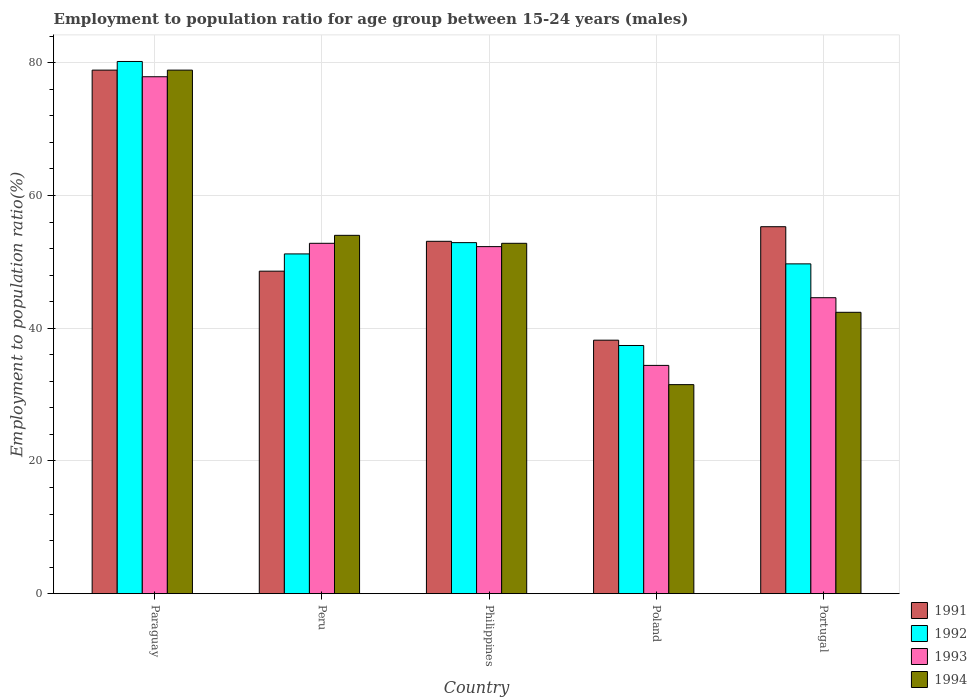How many different coloured bars are there?
Make the answer very short. 4. Are the number of bars on each tick of the X-axis equal?
Your answer should be compact. Yes. How many bars are there on the 4th tick from the left?
Make the answer very short. 4. How many bars are there on the 4th tick from the right?
Give a very brief answer. 4. What is the label of the 2nd group of bars from the left?
Ensure brevity in your answer.  Peru. What is the employment to population ratio in 1992 in Paraguay?
Offer a very short reply. 80.2. Across all countries, what is the maximum employment to population ratio in 1993?
Give a very brief answer. 77.9. Across all countries, what is the minimum employment to population ratio in 1991?
Provide a succinct answer. 38.2. In which country was the employment to population ratio in 1993 maximum?
Provide a short and direct response. Paraguay. What is the total employment to population ratio in 1991 in the graph?
Your answer should be very brief. 274.1. What is the difference between the employment to population ratio in 1991 in Peru and that in Portugal?
Provide a succinct answer. -6.7. What is the difference between the employment to population ratio in 1994 in Portugal and the employment to population ratio in 1992 in Poland?
Keep it short and to the point. 5. What is the average employment to population ratio in 1992 per country?
Provide a short and direct response. 54.28. What is the difference between the employment to population ratio of/in 1993 and employment to population ratio of/in 1991 in Poland?
Your response must be concise. -3.8. In how many countries, is the employment to population ratio in 1992 greater than 44 %?
Give a very brief answer. 4. What is the ratio of the employment to population ratio in 1992 in Paraguay to that in Portugal?
Keep it short and to the point. 1.61. What is the difference between the highest and the second highest employment to population ratio in 1994?
Offer a very short reply. 1.2. What is the difference between the highest and the lowest employment to population ratio in 1994?
Make the answer very short. 47.4. In how many countries, is the employment to population ratio in 1992 greater than the average employment to population ratio in 1992 taken over all countries?
Your answer should be very brief. 1. Is the sum of the employment to population ratio in 1992 in Peru and Philippines greater than the maximum employment to population ratio in 1993 across all countries?
Offer a terse response. Yes. Is it the case that in every country, the sum of the employment to population ratio in 1992 and employment to population ratio in 1991 is greater than the sum of employment to population ratio in 1994 and employment to population ratio in 1993?
Your answer should be compact. No. How many bars are there?
Give a very brief answer. 20. Are the values on the major ticks of Y-axis written in scientific E-notation?
Ensure brevity in your answer.  No. What is the title of the graph?
Your answer should be very brief. Employment to population ratio for age group between 15-24 years (males). Does "1980" appear as one of the legend labels in the graph?
Provide a succinct answer. No. What is the label or title of the X-axis?
Your answer should be compact. Country. What is the Employment to population ratio(%) in 1991 in Paraguay?
Keep it short and to the point. 78.9. What is the Employment to population ratio(%) in 1992 in Paraguay?
Your answer should be very brief. 80.2. What is the Employment to population ratio(%) of 1993 in Paraguay?
Offer a very short reply. 77.9. What is the Employment to population ratio(%) in 1994 in Paraguay?
Your response must be concise. 78.9. What is the Employment to population ratio(%) in 1991 in Peru?
Your response must be concise. 48.6. What is the Employment to population ratio(%) of 1992 in Peru?
Offer a very short reply. 51.2. What is the Employment to population ratio(%) of 1993 in Peru?
Provide a succinct answer. 52.8. What is the Employment to population ratio(%) in 1994 in Peru?
Your response must be concise. 54. What is the Employment to population ratio(%) of 1991 in Philippines?
Ensure brevity in your answer.  53.1. What is the Employment to population ratio(%) in 1992 in Philippines?
Offer a very short reply. 52.9. What is the Employment to population ratio(%) of 1993 in Philippines?
Your answer should be very brief. 52.3. What is the Employment to population ratio(%) of 1994 in Philippines?
Provide a short and direct response. 52.8. What is the Employment to population ratio(%) in 1991 in Poland?
Give a very brief answer. 38.2. What is the Employment to population ratio(%) of 1992 in Poland?
Your answer should be very brief. 37.4. What is the Employment to population ratio(%) of 1993 in Poland?
Your answer should be compact. 34.4. What is the Employment to population ratio(%) in 1994 in Poland?
Provide a succinct answer. 31.5. What is the Employment to population ratio(%) in 1991 in Portugal?
Ensure brevity in your answer.  55.3. What is the Employment to population ratio(%) in 1992 in Portugal?
Provide a succinct answer. 49.7. What is the Employment to population ratio(%) in 1993 in Portugal?
Provide a short and direct response. 44.6. What is the Employment to population ratio(%) in 1994 in Portugal?
Keep it short and to the point. 42.4. Across all countries, what is the maximum Employment to population ratio(%) in 1991?
Provide a short and direct response. 78.9. Across all countries, what is the maximum Employment to population ratio(%) in 1992?
Make the answer very short. 80.2. Across all countries, what is the maximum Employment to population ratio(%) in 1993?
Provide a short and direct response. 77.9. Across all countries, what is the maximum Employment to population ratio(%) of 1994?
Your answer should be very brief. 78.9. Across all countries, what is the minimum Employment to population ratio(%) in 1991?
Your answer should be compact. 38.2. Across all countries, what is the minimum Employment to population ratio(%) in 1992?
Ensure brevity in your answer.  37.4. Across all countries, what is the minimum Employment to population ratio(%) of 1993?
Offer a terse response. 34.4. Across all countries, what is the minimum Employment to population ratio(%) in 1994?
Provide a short and direct response. 31.5. What is the total Employment to population ratio(%) of 1991 in the graph?
Offer a terse response. 274.1. What is the total Employment to population ratio(%) in 1992 in the graph?
Ensure brevity in your answer.  271.4. What is the total Employment to population ratio(%) in 1993 in the graph?
Your answer should be very brief. 262. What is the total Employment to population ratio(%) of 1994 in the graph?
Your answer should be very brief. 259.6. What is the difference between the Employment to population ratio(%) of 1991 in Paraguay and that in Peru?
Give a very brief answer. 30.3. What is the difference between the Employment to population ratio(%) of 1993 in Paraguay and that in Peru?
Offer a terse response. 25.1. What is the difference between the Employment to population ratio(%) in 1994 in Paraguay and that in Peru?
Provide a short and direct response. 24.9. What is the difference between the Employment to population ratio(%) in 1991 in Paraguay and that in Philippines?
Provide a succinct answer. 25.8. What is the difference between the Employment to population ratio(%) in 1992 in Paraguay and that in Philippines?
Your answer should be compact. 27.3. What is the difference between the Employment to population ratio(%) of 1993 in Paraguay and that in Philippines?
Ensure brevity in your answer.  25.6. What is the difference between the Employment to population ratio(%) in 1994 in Paraguay and that in Philippines?
Keep it short and to the point. 26.1. What is the difference between the Employment to population ratio(%) in 1991 in Paraguay and that in Poland?
Keep it short and to the point. 40.7. What is the difference between the Employment to population ratio(%) of 1992 in Paraguay and that in Poland?
Offer a terse response. 42.8. What is the difference between the Employment to population ratio(%) of 1993 in Paraguay and that in Poland?
Offer a terse response. 43.5. What is the difference between the Employment to population ratio(%) in 1994 in Paraguay and that in Poland?
Your answer should be very brief. 47.4. What is the difference between the Employment to population ratio(%) in 1991 in Paraguay and that in Portugal?
Your answer should be compact. 23.6. What is the difference between the Employment to population ratio(%) in 1992 in Paraguay and that in Portugal?
Offer a terse response. 30.5. What is the difference between the Employment to population ratio(%) of 1993 in Paraguay and that in Portugal?
Your answer should be compact. 33.3. What is the difference between the Employment to population ratio(%) of 1994 in Paraguay and that in Portugal?
Ensure brevity in your answer.  36.5. What is the difference between the Employment to population ratio(%) of 1991 in Peru and that in Philippines?
Provide a succinct answer. -4.5. What is the difference between the Employment to population ratio(%) of 1992 in Peru and that in Philippines?
Ensure brevity in your answer.  -1.7. What is the difference between the Employment to population ratio(%) in 1993 in Peru and that in Philippines?
Give a very brief answer. 0.5. What is the difference between the Employment to population ratio(%) in 1994 in Peru and that in Philippines?
Ensure brevity in your answer.  1.2. What is the difference between the Employment to population ratio(%) of 1992 in Peru and that in Poland?
Make the answer very short. 13.8. What is the difference between the Employment to population ratio(%) in 1992 in Peru and that in Portugal?
Offer a terse response. 1.5. What is the difference between the Employment to population ratio(%) of 1993 in Peru and that in Portugal?
Make the answer very short. 8.2. What is the difference between the Employment to population ratio(%) in 1994 in Peru and that in Portugal?
Ensure brevity in your answer.  11.6. What is the difference between the Employment to population ratio(%) in 1992 in Philippines and that in Poland?
Your response must be concise. 15.5. What is the difference between the Employment to population ratio(%) in 1994 in Philippines and that in Poland?
Your answer should be compact. 21.3. What is the difference between the Employment to population ratio(%) in 1992 in Philippines and that in Portugal?
Your answer should be compact. 3.2. What is the difference between the Employment to population ratio(%) in 1993 in Philippines and that in Portugal?
Give a very brief answer. 7.7. What is the difference between the Employment to population ratio(%) of 1991 in Poland and that in Portugal?
Your response must be concise. -17.1. What is the difference between the Employment to population ratio(%) of 1993 in Poland and that in Portugal?
Offer a terse response. -10.2. What is the difference between the Employment to population ratio(%) of 1994 in Poland and that in Portugal?
Offer a terse response. -10.9. What is the difference between the Employment to population ratio(%) in 1991 in Paraguay and the Employment to population ratio(%) in 1992 in Peru?
Provide a short and direct response. 27.7. What is the difference between the Employment to population ratio(%) of 1991 in Paraguay and the Employment to population ratio(%) of 1993 in Peru?
Keep it short and to the point. 26.1. What is the difference between the Employment to population ratio(%) of 1991 in Paraguay and the Employment to population ratio(%) of 1994 in Peru?
Ensure brevity in your answer.  24.9. What is the difference between the Employment to population ratio(%) of 1992 in Paraguay and the Employment to population ratio(%) of 1993 in Peru?
Offer a very short reply. 27.4. What is the difference between the Employment to population ratio(%) of 1992 in Paraguay and the Employment to population ratio(%) of 1994 in Peru?
Your response must be concise. 26.2. What is the difference between the Employment to population ratio(%) of 1993 in Paraguay and the Employment to population ratio(%) of 1994 in Peru?
Give a very brief answer. 23.9. What is the difference between the Employment to population ratio(%) in 1991 in Paraguay and the Employment to population ratio(%) in 1993 in Philippines?
Offer a terse response. 26.6. What is the difference between the Employment to population ratio(%) in 1991 in Paraguay and the Employment to population ratio(%) in 1994 in Philippines?
Your answer should be very brief. 26.1. What is the difference between the Employment to population ratio(%) of 1992 in Paraguay and the Employment to population ratio(%) of 1993 in Philippines?
Provide a short and direct response. 27.9. What is the difference between the Employment to population ratio(%) in 1992 in Paraguay and the Employment to population ratio(%) in 1994 in Philippines?
Provide a succinct answer. 27.4. What is the difference between the Employment to population ratio(%) of 1993 in Paraguay and the Employment to population ratio(%) of 1994 in Philippines?
Make the answer very short. 25.1. What is the difference between the Employment to population ratio(%) in 1991 in Paraguay and the Employment to population ratio(%) in 1992 in Poland?
Offer a terse response. 41.5. What is the difference between the Employment to population ratio(%) in 1991 in Paraguay and the Employment to population ratio(%) in 1993 in Poland?
Your answer should be compact. 44.5. What is the difference between the Employment to population ratio(%) in 1991 in Paraguay and the Employment to population ratio(%) in 1994 in Poland?
Your response must be concise. 47.4. What is the difference between the Employment to population ratio(%) in 1992 in Paraguay and the Employment to population ratio(%) in 1993 in Poland?
Your response must be concise. 45.8. What is the difference between the Employment to population ratio(%) of 1992 in Paraguay and the Employment to population ratio(%) of 1994 in Poland?
Provide a short and direct response. 48.7. What is the difference between the Employment to population ratio(%) in 1993 in Paraguay and the Employment to population ratio(%) in 1994 in Poland?
Your answer should be compact. 46.4. What is the difference between the Employment to population ratio(%) of 1991 in Paraguay and the Employment to population ratio(%) of 1992 in Portugal?
Provide a succinct answer. 29.2. What is the difference between the Employment to population ratio(%) in 1991 in Paraguay and the Employment to population ratio(%) in 1993 in Portugal?
Offer a very short reply. 34.3. What is the difference between the Employment to population ratio(%) in 1991 in Paraguay and the Employment to population ratio(%) in 1994 in Portugal?
Provide a succinct answer. 36.5. What is the difference between the Employment to population ratio(%) in 1992 in Paraguay and the Employment to population ratio(%) in 1993 in Portugal?
Provide a succinct answer. 35.6. What is the difference between the Employment to population ratio(%) of 1992 in Paraguay and the Employment to population ratio(%) of 1994 in Portugal?
Your answer should be compact. 37.8. What is the difference between the Employment to population ratio(%) in 1993 in Paraguay and the Employment to population ratio(%) in 1994 in Portugal?
Your answer should be very brief. 35.5. What is the difference between the Employment to population ratio(%) in 1991 in Peru and the Employment to population ratio(%) in 1992 in Philippines?
Offer a very short reply. -4.3. What is the difference between the Employment to population ratio(%) of 1992 in Peru and the Employment to population ratio(%) of 1993 in Philippines?
Your answer should be compact. -1.1. What is the difference between the Employment to population ratio(%) of 1992 in Peru and the Employment to population ratio(%) of 1994 in Philippines?
Make the answer very short. -1.6. What is the difference between the Employment to population ratio(%) of 1991 in Peru and the Employment to population ratio(%) of 1992 in Poland?
Provide a short and direct response. 11.2. What is the difference between the Employment to population ratio(%) in 1991 in Peru and the Employment to population ratio(%) in 1993 in Poland?
Give a very brief answer. 14.2. What is the difference between the Employment to population ratio(%) of 1992 in Peru and the Employment to population ratio(%) of 1993 in Poland?
Your response must be concise. 16.8. What is the difference between the Employment to population ratio(%) of 1992 in Peru and the Employment to population ratio(%) of 1994 in Poland?
Ensure brevity in your answer.  19.7. What is the difference between the Employment to population ratio(%) of 1993 in Peru and the Employment to population ratio(%) of 1994 in Poland?
Provide a succinct answer. 21.3. What is the difference between the Employment to population ratio(%) of 1991 in Peru and the Employment to population ratio(%) of 1992 in Portugal?
Your answer should be compact. -1.1. What is the difference between the Employment to population ratio(%) in 1992 in Peru and the Employment to population ratio(%) in 1994 in Portugal?
Offer a very short reply. 8.8. What is the difference between the Employment to population ratio(%) of 1993 in Peru and the Employment to population ratio(%) of 1994 in Portugal?
Give a very brief answer. 10.4. What is the difference between the Employment to population ratio(%) of 1991 in Philippines and the Employment to population ratio(%) of 1992 in Poland?
Make the answer very short. 15.7. What is the difference between the Employment to population ratio(%) in 1991 in Philippines and the Employment to population ratio(%) in 1993 in Poland?
Your response must be concise. 18.7. What is the difference between the Employment to population ratio(%) in 1991 in Philippines and the Employment to population ratio(%) in 1994 in Poland?
Provide a succinct answer. 21.6. What is the difference between the Employment to population ratio(%) in 1992 in Philippines and the Employment to population ratio(%) in 1994 in Poland?
Offer a terse response. 21.4. What is the difference between the Employment to population ratio(%) in 1993 in Philippines and the Employment to population ratio(%) in 1994 in Poland?
Keep it short and to the point. 20.8. What is the difference between the Employment to population ratio(%) in 1991 in Philippines and the Employment to population ratio(%) in 1992 in Portugal?
Give a very brief answer. 3.4. What is the difference between the Employment to population ratio(%) of 1992 in Philippines and the Employment to population ratio(%) of 1993 in Portugal?
Keep it short and to the point. 8.3. What is the difference between the Employment to population ratio(%) in 1991 in Poland and the Employment to population ratio(%) in 1992 in Portugal?
Give a very brief answer. -11.5. What is the difference between the Employment to population ratio(%) in 1991 in Poland and the Employment to population ratio(%) in 1993 in Portugal?
Your answer should be compact. -6.4. What is the difference between the Employment to population ratio(%) of 1992 in Poland and the Employment to population ratio(%) of 1993 in Portugal?
Keep it short and to the point. -7.2. What is the average Employment to population ratio(%) in 1991 per country?
Provide a short and direct response. 54.82. What is the average Employment to population ratio(%) of 1992 per country?
Offer a terse response. 54.28. What is the average Employment to population ratio(%) of 1993 per country?
Provide a short and direct response. 52.4. What is the average Employment to population ratio(%) in 1994 per country?
Provide a succinct answer. 51.92. What is the difference between the Employment to population ratio(%) of 1991 and Employment to population ratio(%) of 1994 in Paraguay?
Give a very brief answer. 0. What is the difference between the Employment to population ratio(%) of 1992 and Employment to population ratio(%) of 1994 in Paraguay?
Offer a terse response. 1.3. What is the difference between the Employment to population ratio(%) of 1991 and Employment to population ratio(%) of 1994 in Peru?
Your response must be concise. -5.4. What is the difference between the Employment to population ratio(%) in 1993 and Employment to population ratio(%) in 1994 in Peru?
Provide a succinct answer. -1.2. What is the difference between the Employment to population ratio(%) of 1991 and Employment to population ratio(%) of 1994 in Philippines?
Offer a terse response. 0.3. What is the difference between the Employment to population ratio(%) in 1991 and Employment to population ratio(%) in 1992 in Poland?
Offer a terse response. 0.8. What is the difference between the Employment to population ratio(%) of 1992 and Employment to population ratio(%) of 1993 in Poland?
Ensure brevity in your answer.  3. What is the difference between the Employment to population ratio(%) in 1992 and Employment to population ratio(%) in 1994 in Poland?
Make the answer very short. 5.9. What is the difference between the Employment to population ratio(%) of 1991 and Employment to population ratio(%) of 1994 in Portugal?
Keep it short and to the point. 12.9. What is the difference between the Employment to population ratio(%) of 1992 and Employment to population ratio(%) of 1993 in Portugal?
Ensure brevity in your answer.  5.1. What is the difference between the Employment to population ratio(%) in 1992 and Employment to population ratio(%) in 1994 in Portugal?
Your answer should be compact. 7.3. What is the ratio of the Employment to population ratio(%) in 1991 in Paraguay to that in Peru?
Ensure brevity in your answer.  1.62. What is the ratio of the Employment to population ratio(%) in 1992 in Paraguay to that in Peru?
Give a very brief answer. 1.57. What is the ratio of the Employment to population ratio(%) of 1993 in Paraguay to that in Peru?
Provide a short and direct response. 1.48. What is the ratio of the Employment to population ratio(%) in 1994 in Paraguay to that in Peru?
Ensure brevity in your answer.  1.46. What is the ratio of the Employment to population ratio(%) in 1991 in Paraguay to that in Philippines?
Ensure brevity in your answer.  1.49. What is the ratio of the Employment to population ratio(%) of 1992 in Paraguay to that in Philippines?
Your answer should be compact. 1.52. What is the ratio of the Employment to population ratio(%) of 1993 in Paraguay to that in Philippines?
Offer a very short reply. 1.49. What is the ratio of the Employment to population ratio(%) in 1994 in Paraguay to that in Philippines?
Provide a short and direct response. 1.49. What is the ratio of the Employment to population ratio(%) in 1991 in Paraguay to that in Poland?
Offer a terse response. 2.07. What is the ratio of the Employment to population ratio(%) in 1992 in Paraguay to that in Poland?
Provide a succinct answer. 2.14. What is the ratio of the Employment to population ratio(%) of 1993 in Paraguay to that in Poland?
Offer a terse response. 2.26. What is the ratio of the Employment to population ratio(%) in 1994 in Paraguay to that in Poland?
Your answer should be compact. 2.5. What is the ratio of the Employment to population ratio(%) in 1991 in Paraguay to that in Portugal?
Ensure brevity in your answer.  1.43. What is the ratio of the Employment to population ratio(%) in 1992 in Paraguay to that in Portugal?
Make the answer very short. 1.61. What is the ratio of the Employment to population ratio(%) of 1993 in Paraguay to that in Portugal?
Keep it short and to the point. 1.75. What is the ratio of the Employment to population ratio(%) of 1994 in Paraguay to that in Portugal?
Ensure brevity in your answer.  1.86. What is the ratio of the Employment to population ratio(%) of 1991 in Peru to that in Philippines?
Your response must be concise. 0.92. What is the ratio of the Employment to population ratio(%) of 1992 in Peru to that in Philippines?
Your answer should be compact. 0.97. What is the ratio of the Employment to population ratio(%) in 1993 in Peru to that in Philippines?
Offer a terse response. 1.01. What is the ratio of the Employment to population ratio(%) in 1994 in Peru to that in Philippines?
Ensure brevity in your answer.  1.02. What is the ratio of the Employment to population ratio(%) of 1991 in Peru to that in Poland?
Your response must be concise. 1.27. What is the ratio of the Employment to population ratio(%) of 1992 in Peru to that in Poland?
Ensure brevity in your answer.  1.37. What is the ratio of the Employment to population ratio(%) of 1993 in Peru to that in Poland?
Ensure brevity in your answer.  1.53. What is the ratio of the Employment to population ratio(%) of 1994 in Peru to that in Poland?
Offer a terse response. 1.71. What is the ratio of the Employment to population ratio(%) in 1991 in Peru to that in Portugal?
Offer a terse response. 0.88. What is the ratio of the Employment to population ratio(%) in 1992 in Peru to that in Portugal?
Your answer should be compact. 1.03. What is the ratio of the Employment to population ratio(%) of 1993 in Peru to that in Portugal?
Ensure brevity in your answer.  1.18. What is the ratio of the Employment to population ratio(%) in 1994 in Peru to that in Portugal?
Give a very brief answer. 1.27. What is the ratio of the Employment to population ratio(%) in 1991 in Philippines to that in Poland?
Keep it short and to the point. 1.39. What is the ratio of the Employment to population ratio(%) in 1992 in Philippines to that in Poland?
Keep it short and to the point. 1.41. What is the ratio of the Employment to population ratio(%) in 1993 in Philippines to that in Poland?
Provide a succinct answer. 1.52. What is the ratio of the Employment to population ratio(%) of 1994 in Philippines to that in Poland?
Make the answer very short. 1.68. What is the ratio of the Employment to population ratio(%) of 1991 in Philippines to that in Portugal?
Provide a succinct answer. 0.96. What is the ratio of the Employment to population ratio(%) of 1992 in Philippines to that in Portugal?
Keep it short and to the point. 1.06. What is the ratio of the Employment to population ratio(%) of 1993 in Philippines to that in Portugal?
Give a very brief answer. 1.17. What is the ratio of the Employment to population ratio(%) of 1994 in Philippines to that in Portugal?
Offer a terse response. 1.25. What is the ratio of the Employment to population ratio(%) of 1991 in Poland to that in Portugal?
Give a very brief answer. 0.69. What is the ratio of the Employment to population ratio(%) in 1992 in Poland to that in Portugal?
Offer a very short reply. 0.75. What is the ratio of the Employment to population ratio(%) of 1993 in Poland to that in Portugal?
Offer a terse response. 0.77. What is the ratio of the Employment to population ratio(%) of 1994 in Poland to that in Portugal?
Offer a very short reply. 0.74. What is the difference between the highest and the second highest Employment to population ratio(%) in 1991?
Your response must be concise. 23.6. What is the difference between the highest and the second highest Employment to population ratio(%) in 1992?
Your answer should be very brief. 27.3. What is the difference between the highest and the second highest Employment to population ratio(%) of 1993?
Offer a very short reply. 25.1. What is the difference between the highest and the second highest Employment to population ratio(%) in 1994?
Your answer should be compact. 24.9. What is the difference between the highest and the lowest Employment to population ratio(%) in 1991?
Keep it short and to the point. 40.7. What is the difference between the highest and the lowest Employment to population ratio(%) of 1992?
Offer a terse response. 42.8. What is the difference between the highest and the lowest Employment to population ratio(%) in 1993?
Make the answer very short. 43.5. What is the difference between the highest and the lowest Employment to population ratio(%) in 1994?
Ensure brevity in your answer.  47.4. 